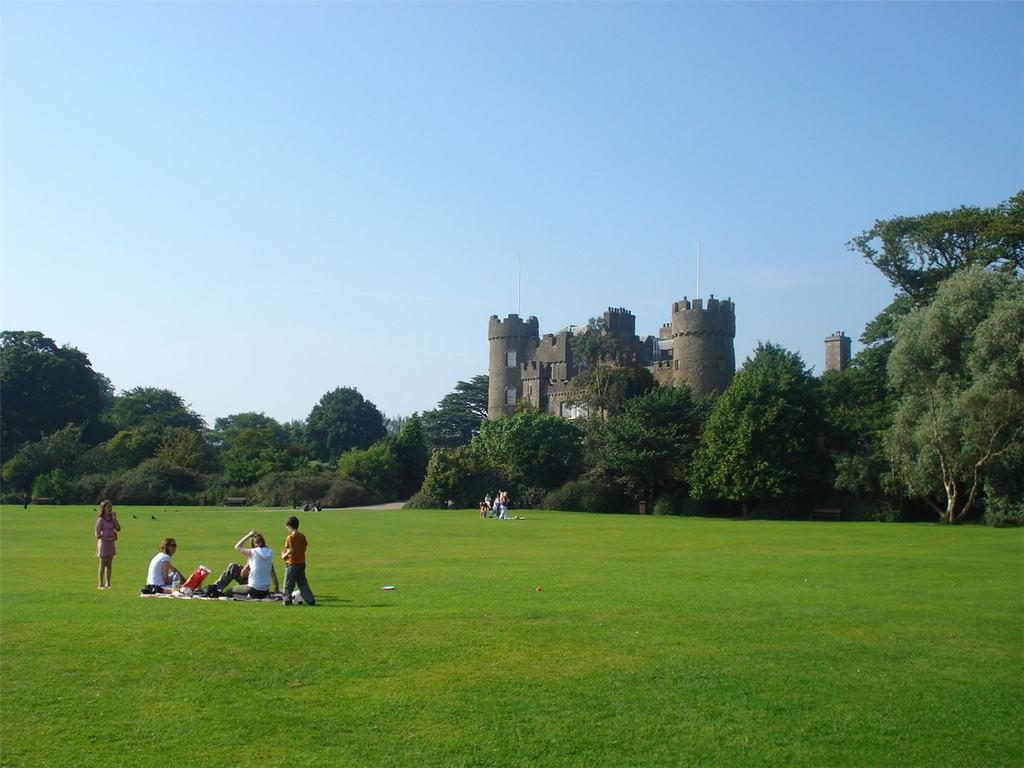How many people are sitting in the image? There are two people sitting in the image. How many people are standing in the image? There are two people standing in the image. What type of structure is depicted in the image? The image appears to depict a castle. What type of vegetation is visible in the image? There are trees in the image. What type of ground cover is visible in the image? There is grass visible in the image. How many people are present in the image? There is a group of people in the image. What part of the natural environment is visible in the image? The sky is visible in the image. What type of collar can be seen on the oil in the image? There is no collar or oil present in the image. 